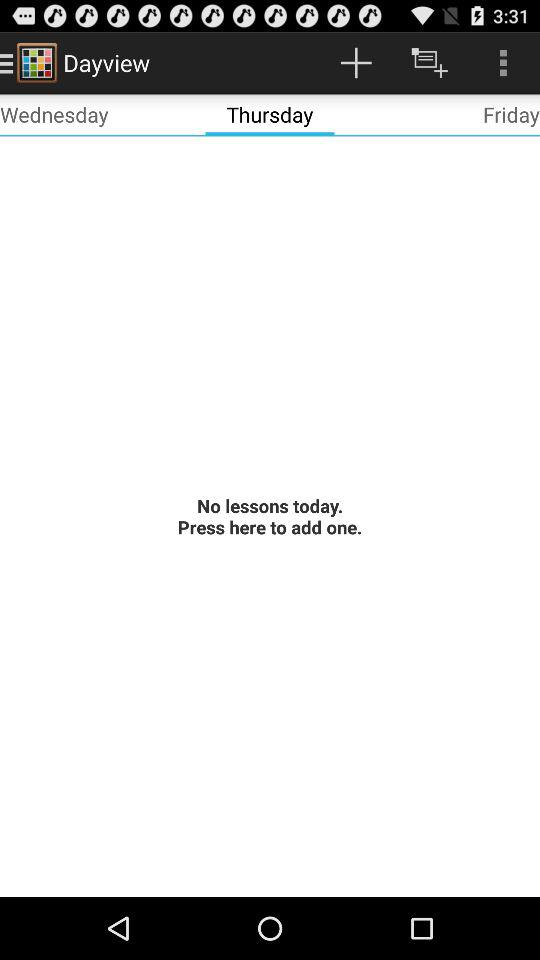How many lessons are there for today?
Answer the question using a single word or phrase. 0 